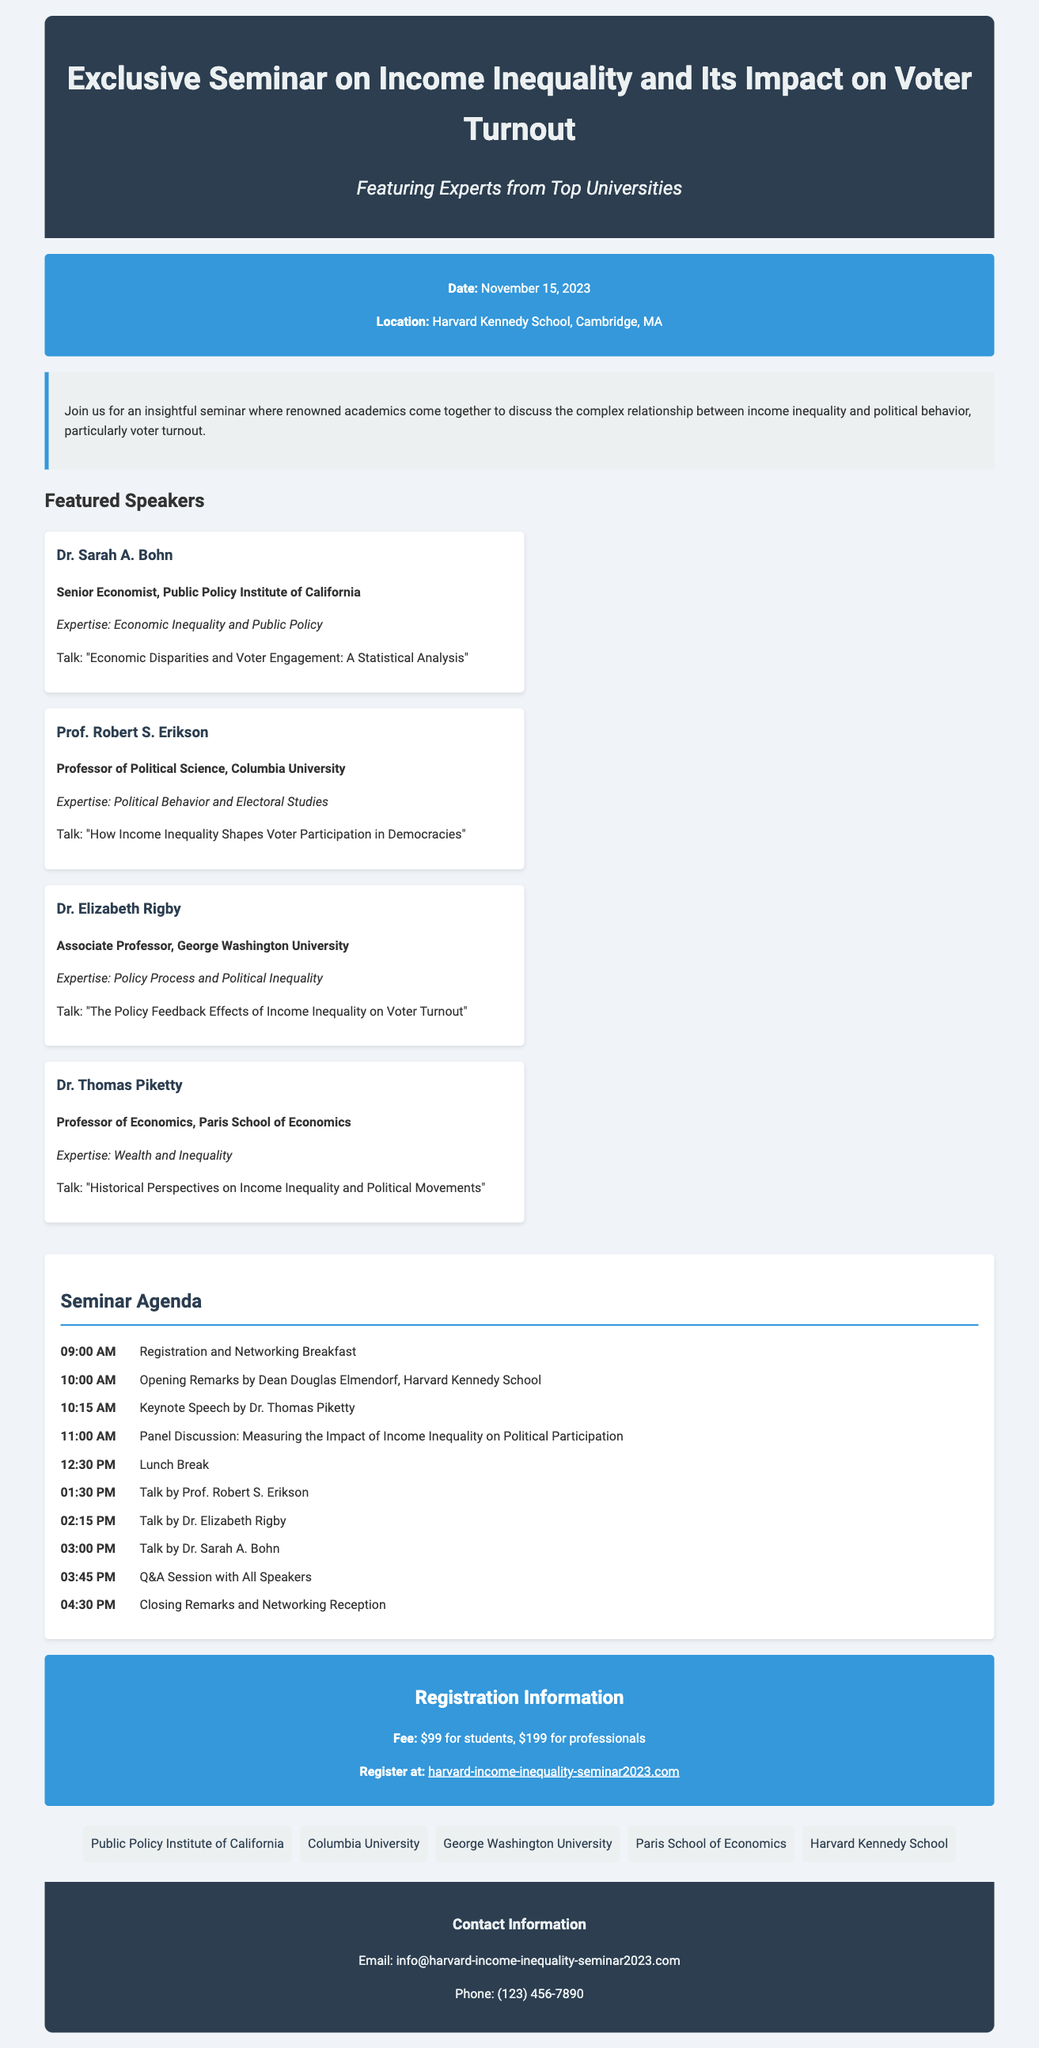What is the date of the seminar? The date of the seminar is explicitly stated in the document.
Answer: November 15, 2023 Where is the seminar being held? The location of the seminar is given in a specific section of the document.
Answer: Harvard Kennedy School, Cambridge, MA Who is the keynote speaker? The document lists the speakers and specifies which one has the keynote speech.
Answer: Dr. Thomas Piketty What is the registration fee for students? The document provides specific registration fee details for different categories of attendees.
Answer: $99 for students What talk does Prof. Robert S. Erikson give? This information can be found in the speaker section under Prof. Robert S. Erikson.
Answer: "How Income Inequality Shapes Voter Participation in Democracies" How long is the lunch break scheduled for? The agenda provides a specific time duration for this break during the seminar.
Answer: 1 hour (from 12:30 PM to 1:30 PM) What is the last event of the seminar? The agenda outlines the structure and order of events, including the final activity.
Answer: Closing Remarks and Networking Reception How many speakers are featured in the seminar? The number of speakers can be counted from the section listing them in the document.
Answer: Four speakers What is the contact email provided for queries? The footer section specifies the contact details for further inquiries.
Answer: info@harvard-income-inequality-seminar2023.com 